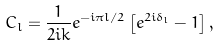<formula> <loc_0><loc_0><loc_500><loc_500>C _ { l } = \frac { 1 } { 2 i k } e ^ { - i \pi l / 2 } \left [ e ^ { 2 i \delta _ { l } } - 1 \right ] ,</formula> 